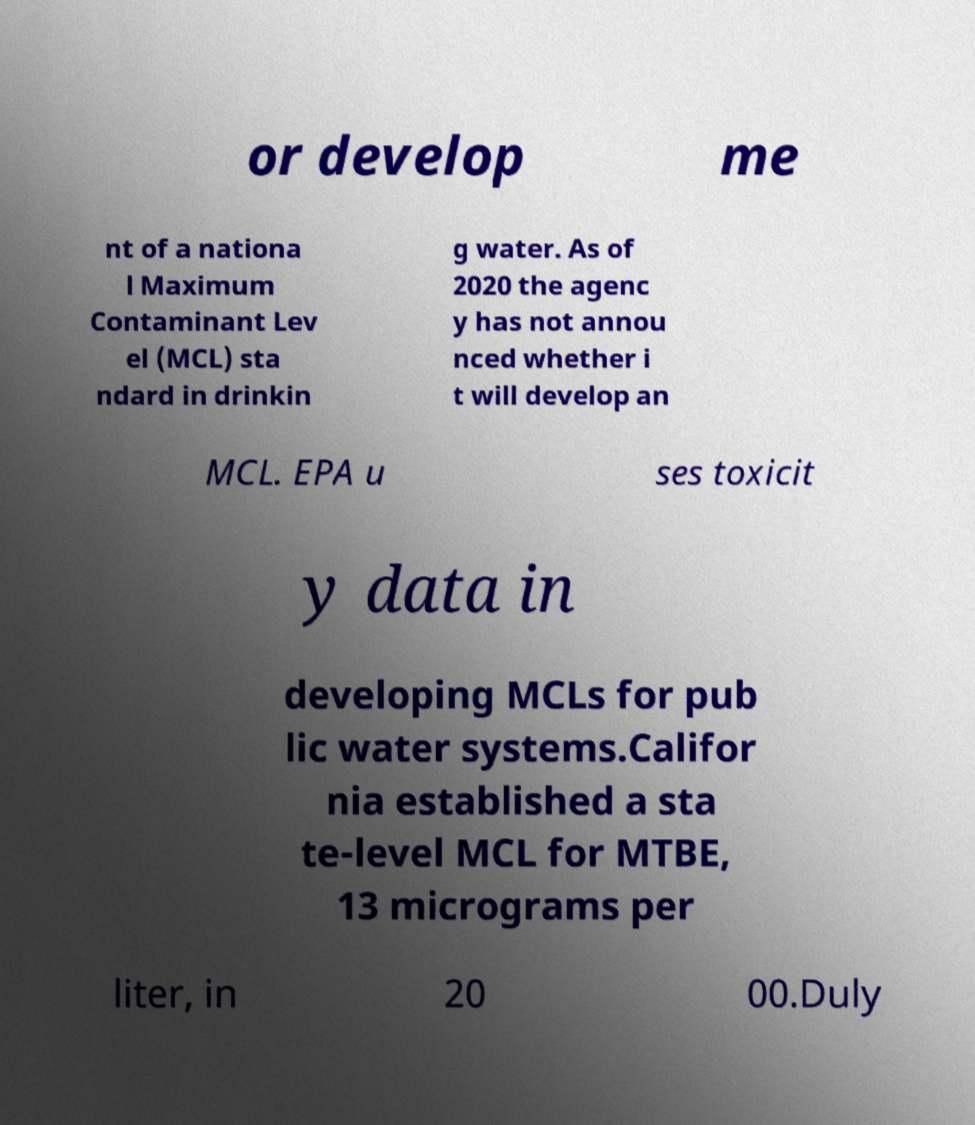For documentation purposes, I need the text within this image transcribed. Could you provide that? or develop me nt of a nationa l Maximum Contaminant Lev el (MCL) sta ndard in drinkin g water. As of 2020 the agenc y has not annou nced whether i t will develop an MCL. EPA u ses toxicit y data in developing MCLs for pub lic water systems.Califor nia established a sta te-level MCL for MTBE, 13 micrograms per liter, in 20 00.Duly 